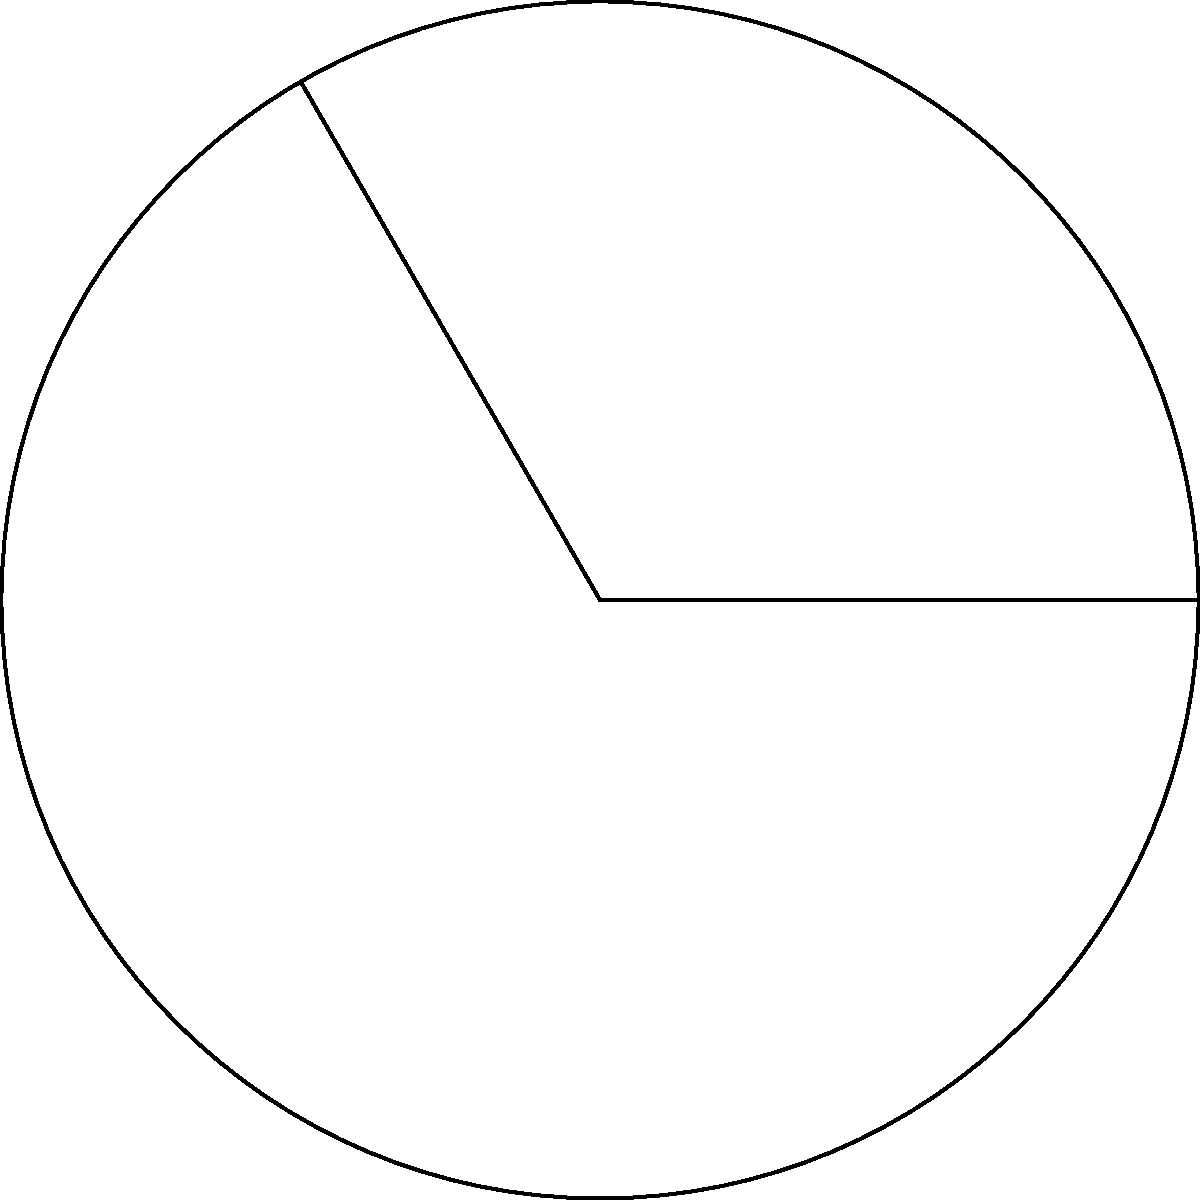As a data scientist analyzing circular patterns in a dataset, you encounter a problem involving a circular sector. Given a circle with radius $r = 5$ cm and a central angle $\theta = 120°$, calculate the area of the circular sector. How would you approach this problem using your domain knowledge of circle geometry? To solve this problem, we'll follow these steps:

1. Recall the formula for the area of a circular sector:
   $$A = \frac{\theta}{360°} \cdot \pi r^2$$
   Where $A$ is the area, $\theta$ is the central angle in degrees, and $r$ is the radius.

2. Identify the given values:
   - Radius $r = 5$ cm
   - Central angle $\theta = 120°$

3. Substitute these values into the formula:
   $$A = \frac{120°}{360°} \cdot \pi (5 \text{ cm})^2$$

4. Simplify the fraction:
   $$A = \frac{1}{3} \cdot \pi (25 \text{ cm}^2)$$

5. Calculate:
   $$A = \frac{25\pi}{3} \text{ cm}^2 \approx 26.18 \text{ cm}^2$$

As a data scientist, it's crucial to understand the underlying geometry before applying formulas or writing code. This approach ensures accurate interpretation of circular patterns in your dataset.
Answer: $\frac{25\pi}{3} \text{ cm}^2$ or approximately $26.18 \text{ cm}^2$ 